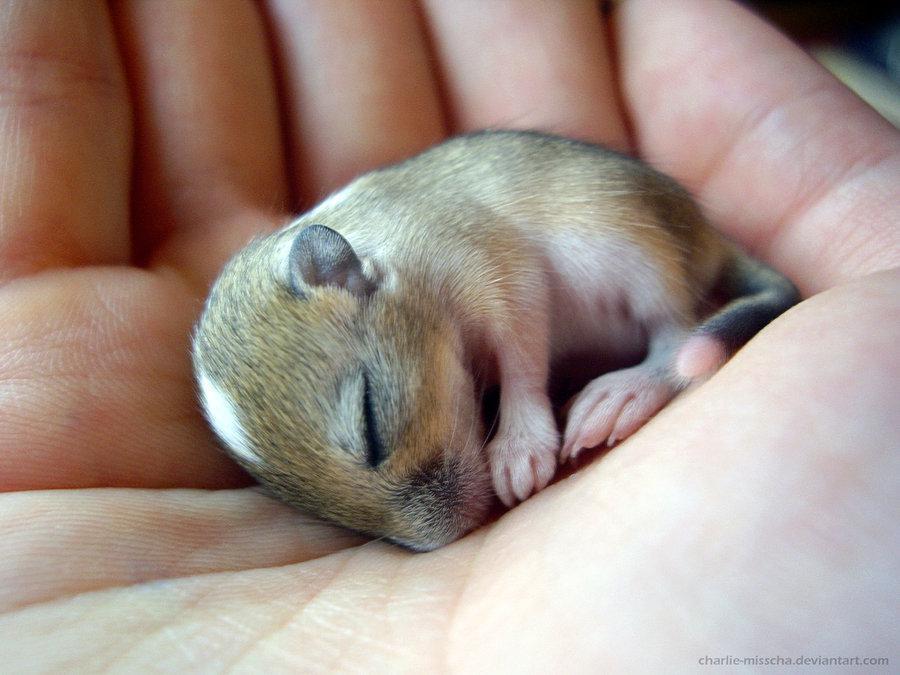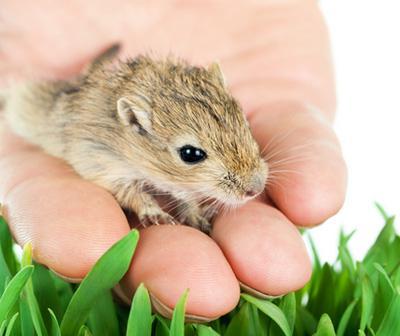The first image is the image on the left, the second image is the image on the right. Examine the images to the left and right. Is the description "At least one of the rodents is resting in a human hand." accurate? Answer yes or no. Yes. 